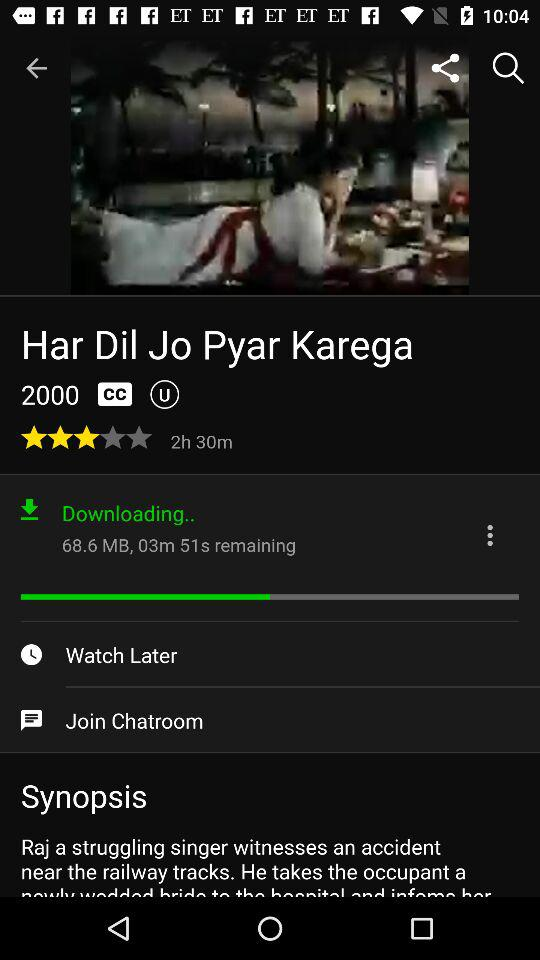How much memory space does the movie "Har Dil Jo Pyar Karega" occupy? The movie occupied 68.6 MB. 